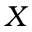<formula> <loc_0><loc_0><loc_500><loc_500>X</formula> 